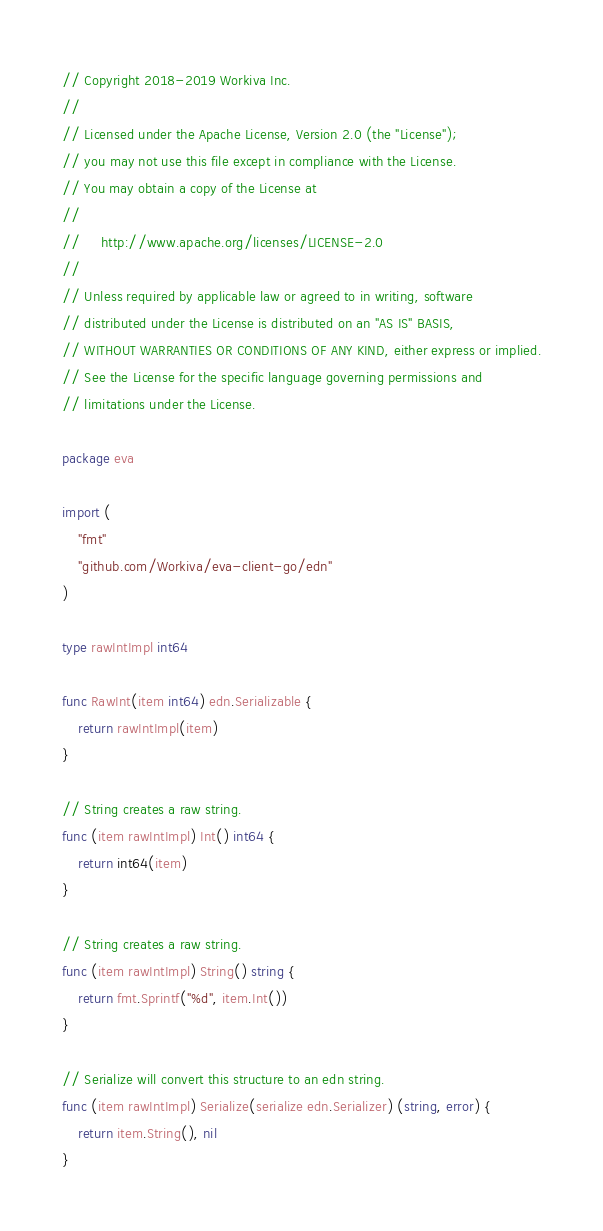<code> <loc_0><loc_0><loc_500><loc_500><_Go_>// Copyright 2018-2019 Workiva Inc.
//
// Licensed under the Apache License, Version 2.0 (the "License");
// you may not use this file except in compliance with the License.
// You may obtain a copy of the License at
//
//     http://www.apache.org/licenses/LICENSE-2.0
//
// Unless required by applicable law or agreed to in writing, software
// distributed under the License is distributed on an "AS IS" BASIS,
// WITHOUT WARRANTIES OR CONDITIONS OF ANY KIND, either express or implied.
// See the License for the specific language governing permissions and
// limitations under the License.

package eva

import (
	"fmt"
	"github.com/Workiva/eva-client-go/edn"
)

type rawIntImpl int64

func RawInt(item int64) edn.Serializable {
	return rawIntImpl(item)
}

// String creates a raw string.
func (item rawIntImpl) Int() int64 {
	return int64(item)
}

// String creates a raw string.
func (item rawIntImpl) String() string {
	return fmt.Sprintf("%d", item.Int())
}

// Serialize will convert this structure to an edn string.
func (item rawIntImpl) Serialize(serialize edn.Serializer) (string, error) {
	return item.String(), nil
}
</code> 